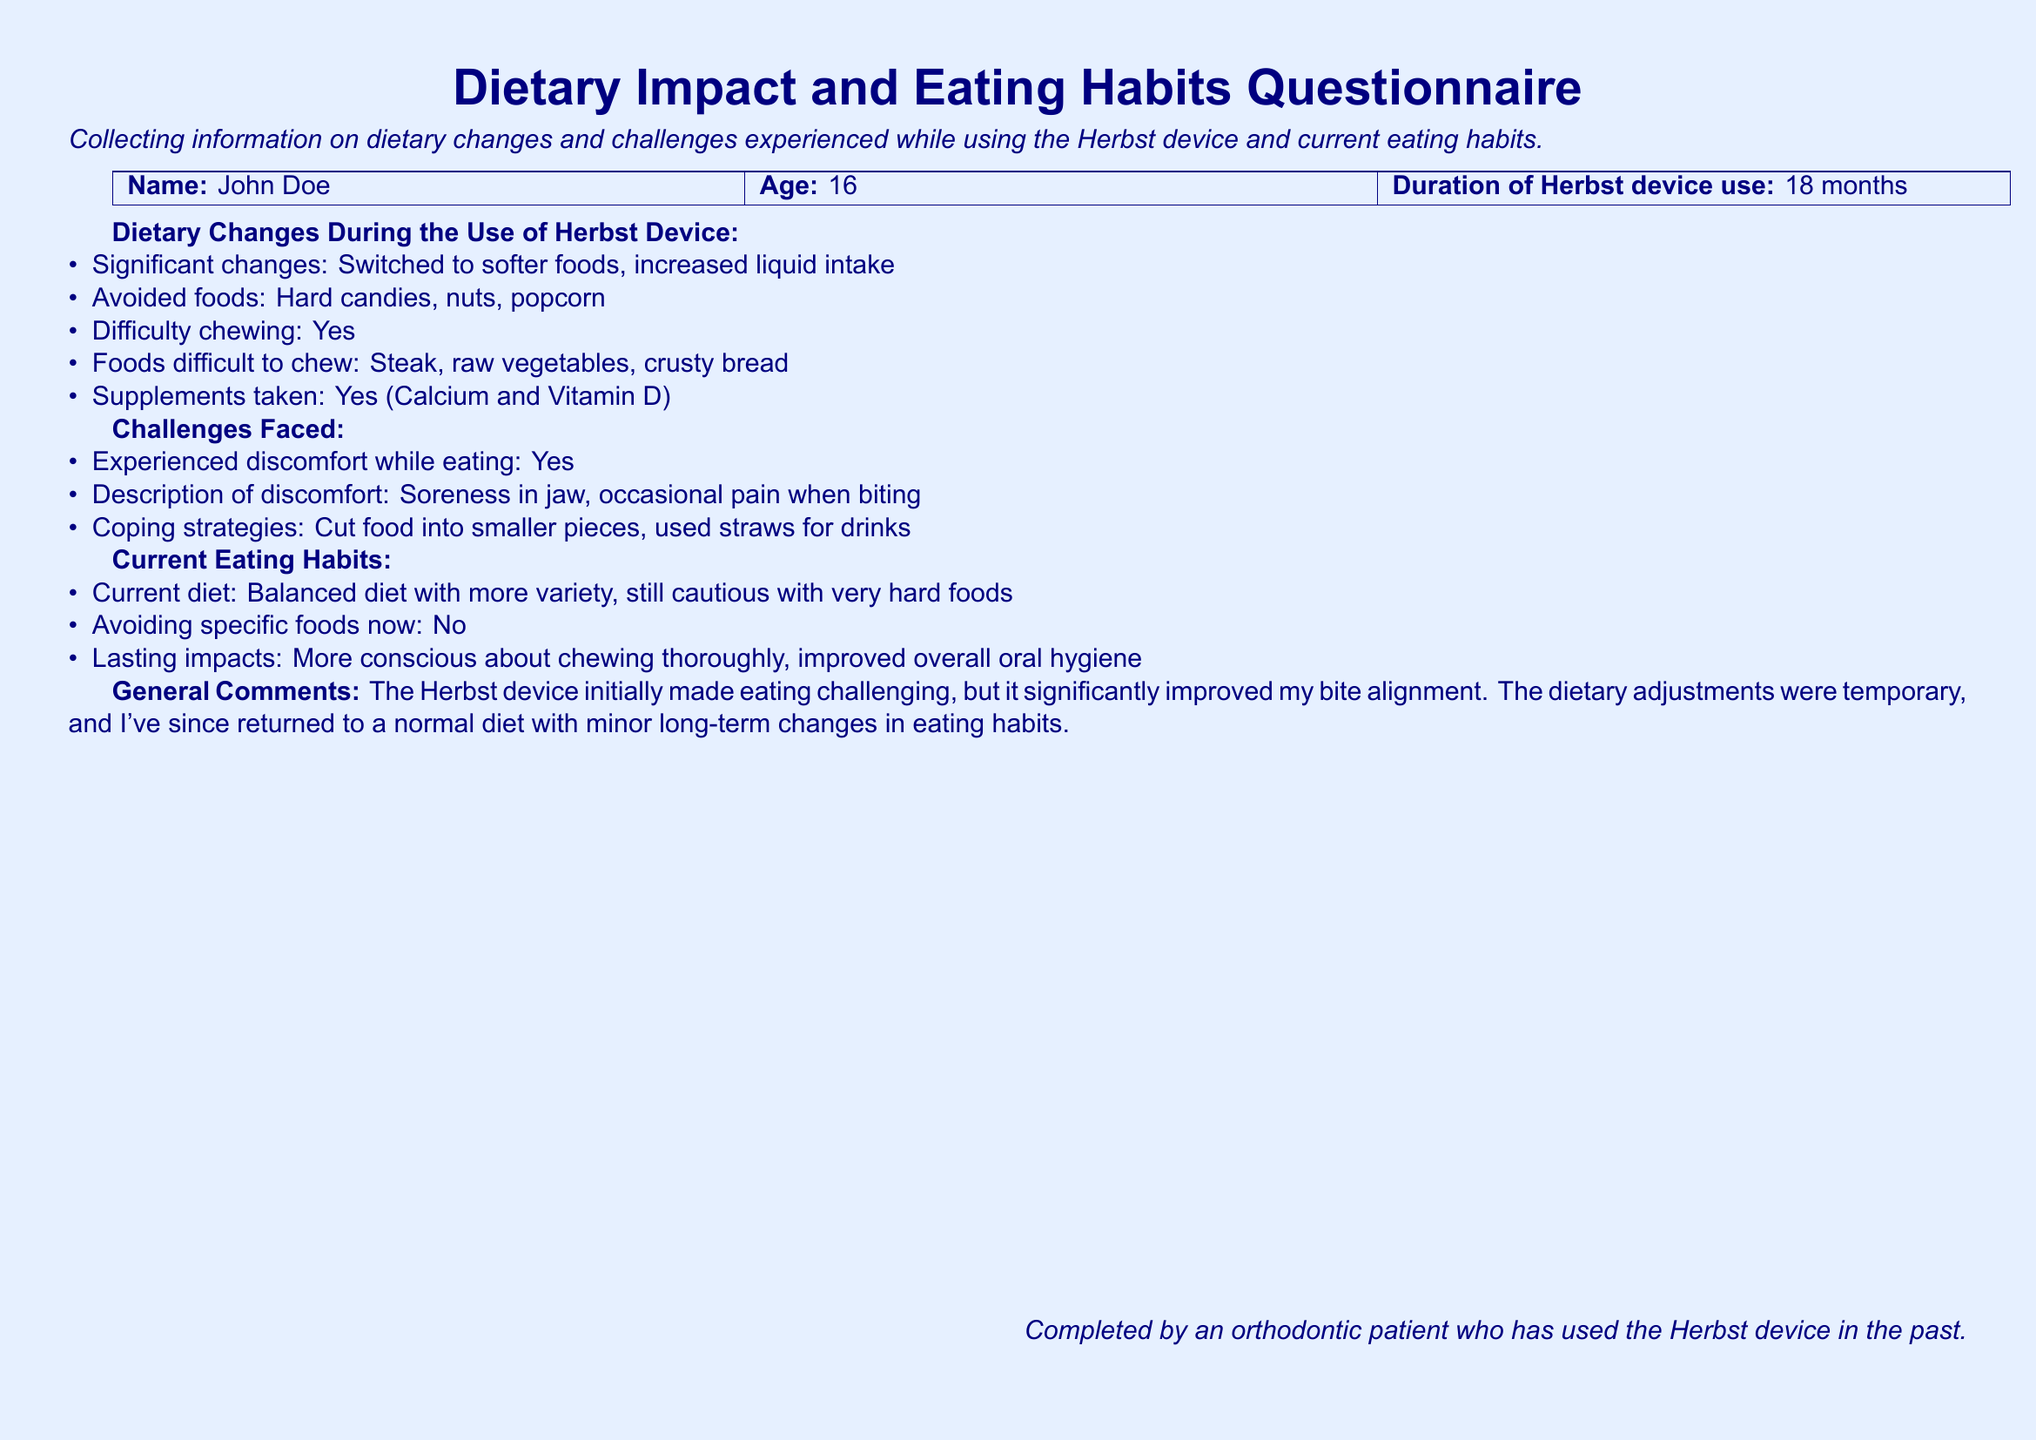what is the name of the patient? The patient's name is provided at the top of the document.
Answer: John Doe how old is the patient? The patient's age is mentioned next to the name in the document.
Answer: 16 how long did the patient use the Herbst device? The duration of use is explicitly stated in the document.
Answer: 18 months what food types did the patient avoid during the use of the Herbst device? The document lists specific foods that were avoided during treatment.
Answer: Hard candies, nuts, popcorn what discomfort did the patient experience while eating? The description of discomfort is provided in the challenges faced section.
Answer: Soreness in jaw, occasional pain when biting what coping strategy did the patient use to manage discomfort? The document mentions specific strategies the patient employed to cope.
Answer: Cut food into smaller pieces, used straws for drinks has the patient returned to a normal diet? The general comments section indicates the changes in diet post-treatment.
Answer: Yes what lasting impacts did the patient mention? The last question in the current eating habits section provides information about lasting changes.
Answer: More conscious about chewing thoroughly, improved overall oral hygiene 